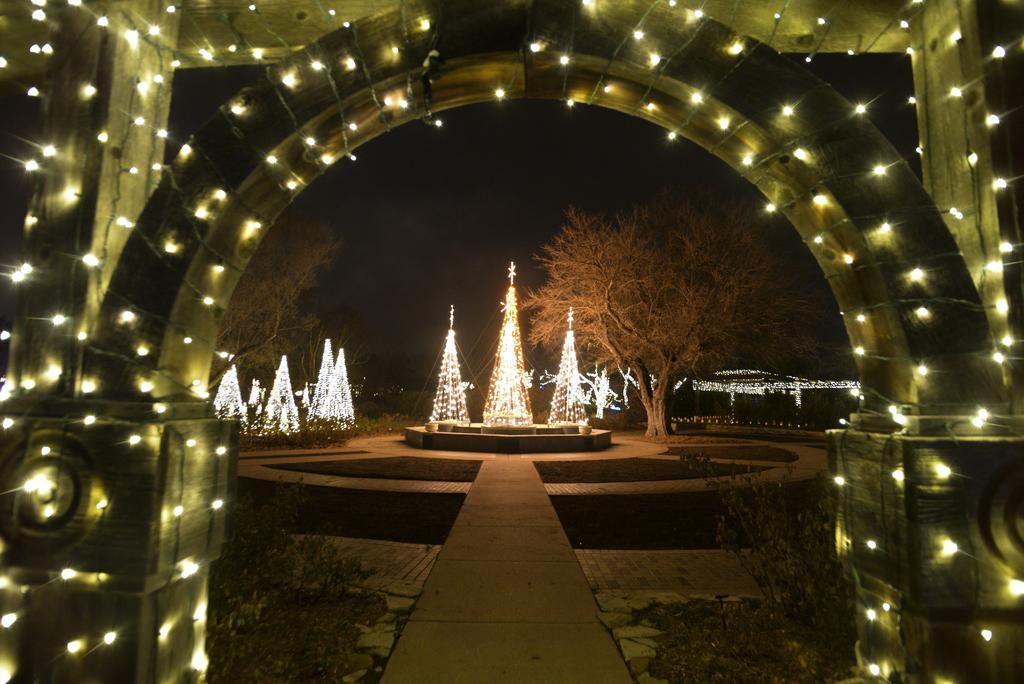Could you give a brief overview of what you see in this image? In this image there is an arch. There are fairy light to the arch. In the center there is a path. There are lights on the trees. The background is dark. 